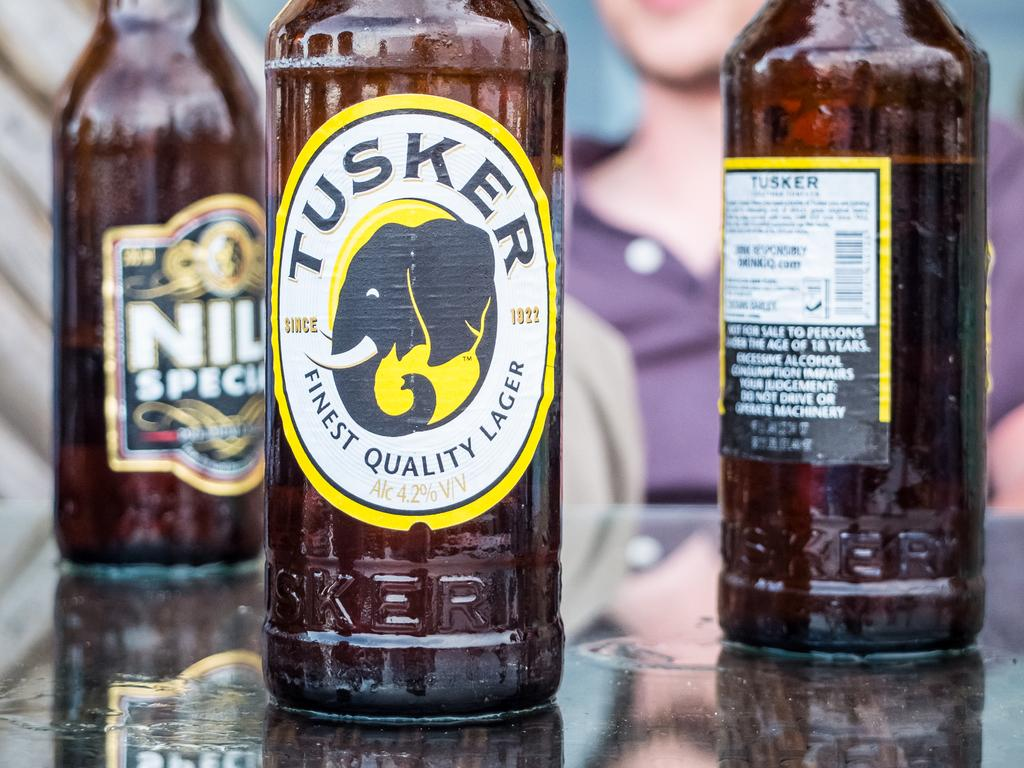<image>
Give a short and clear explanation of the subsequent image. Brown Tusker bottle with an elephant on the label. 